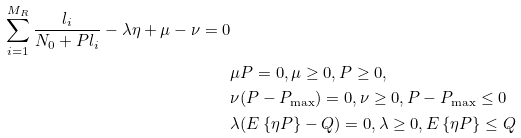Convert formula to latex. <formula><loc_0><loc_0><loc_500><loc_500>{ } \sum _ { i = 1 } ^ { M _ { R } } \frac { l _ { i } } { N _ { 0 } + P l _ { i } } - \lambda \eta + \mu - \nu = 0 \\ & \mu P = 0 , \mu \geq 0 , P \geq 0 , \\ & \nu ( P - P _ { \max } ) = 0 , \nu \geq 0 , P - P _ { \max } \leq 0 \\ & \lambda ( E \left \{ \eta P \right \} - Q ) = 0 , \lambda \geq 0 , E \left \{ \eta P \right \} \leq Q</formula> 